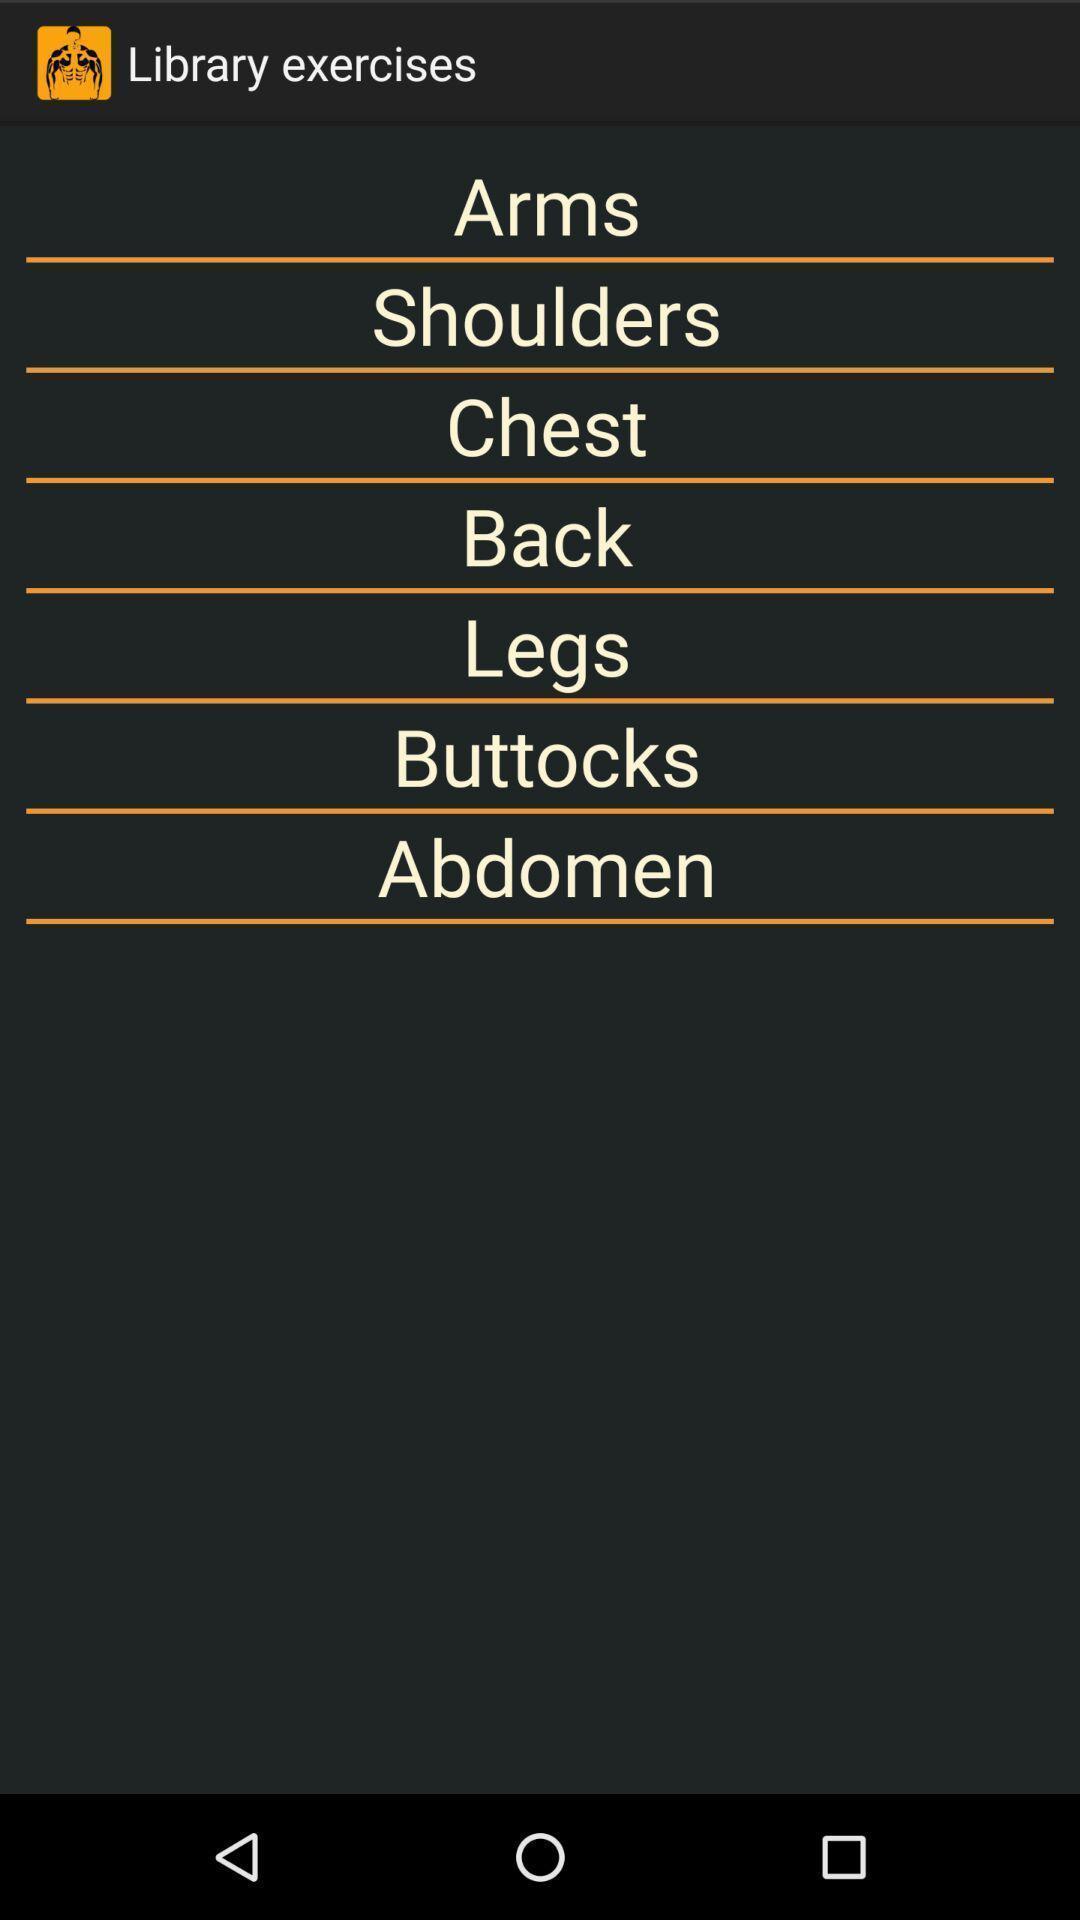Explain what's happening in this screen capture. Screen page showing list of exercises. 